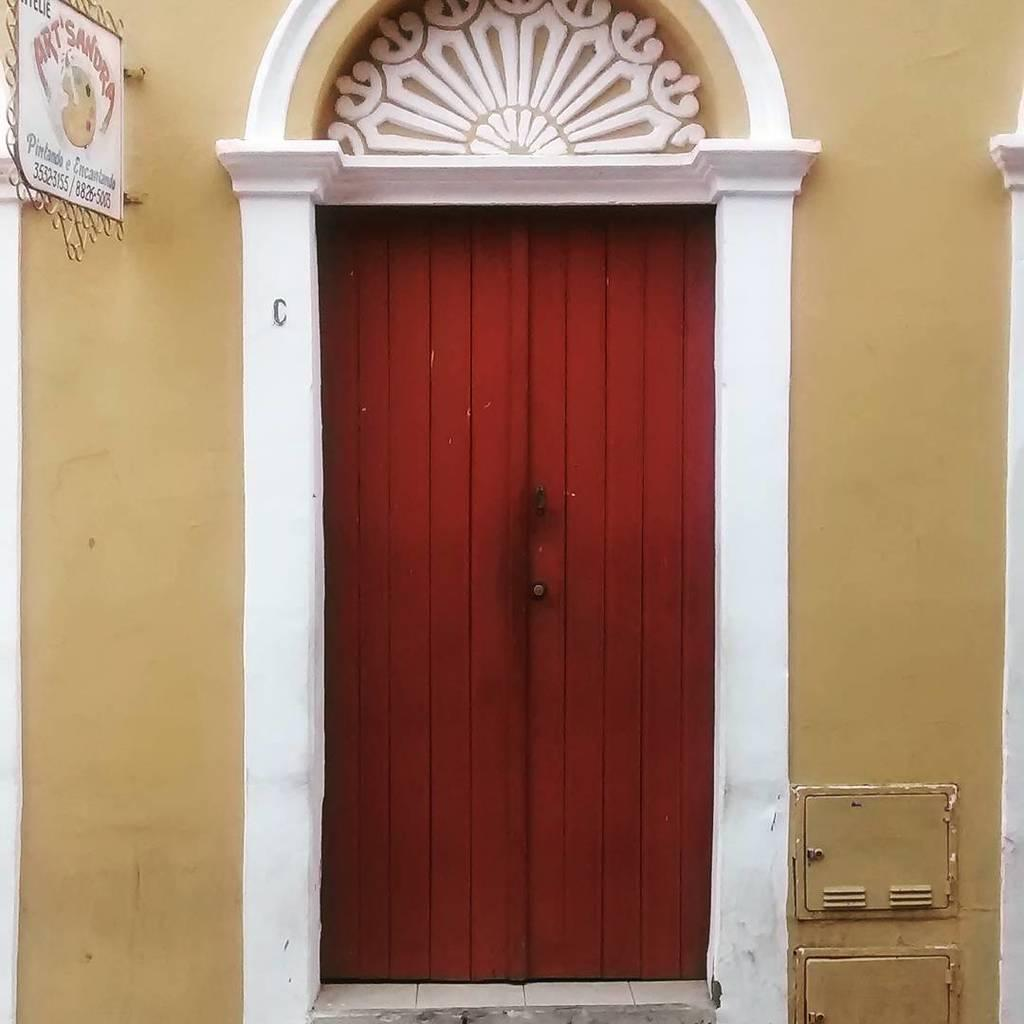What type of structure can be seen in the image? There is a door and walls visible in the image. What is attached to the walls in the image? There is a board in the image. What is written or drawn on the board? The board contains text and a figure. Are there any other objects present in the image? Yes, there are other objects in the image. Can you describe the group of tramps performing a sneeze in the image? There is no group of tramps performing a sneeze in the image. The image contains a door, walls, a board with text and a figure, and other unspecified objects. 